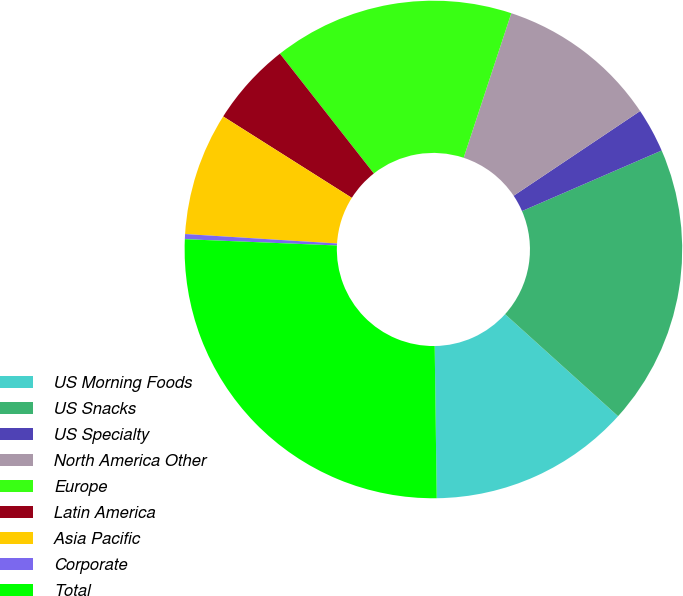Convert chart. <chart><loc_0><loc_0><loc_500><loc_500><pie_chart><fcel>US Morning Foods<fcel>US Snacks<fcel>US Specialty<fcel>North America Other<fcel>Europe<fcel>Latin America<fcel>Asia Pacific<fcel>Corporate<fcel>Total<nl><fcel>13.1%<fcel>18.2%<fcel>2.88%<fcel>10.54%<fcel>15.65%<fcel>5.44%<fcel>7.99%<fcel>0.33%<fcel>25.87%<nl></chart> 